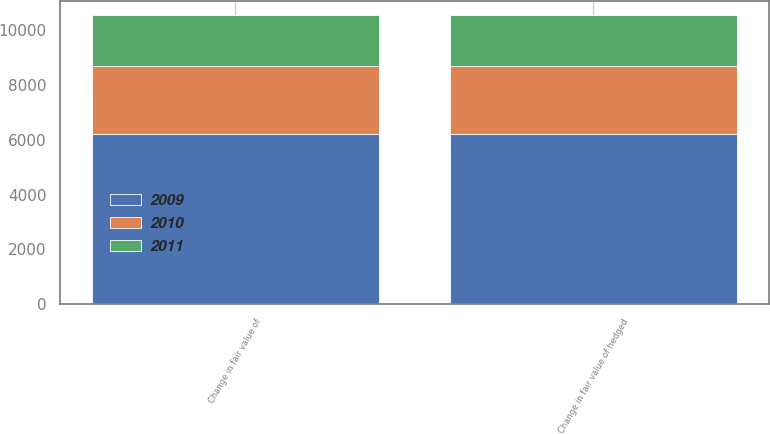Convert chart to OTSL. <chart><loc_0><loc_0><loc_500><loc_500><stacked_bar_chart><ecel><fcel>Change in fair value of<fcel>Change in fair value of hedged<nl><fcel>2010<fcel>2493<fcel>2493<nl><fcel>2011<fcel>1847<fcel>1847<nl><fcel>2009<fcel>6201<fcel>6201<nl></chart> 